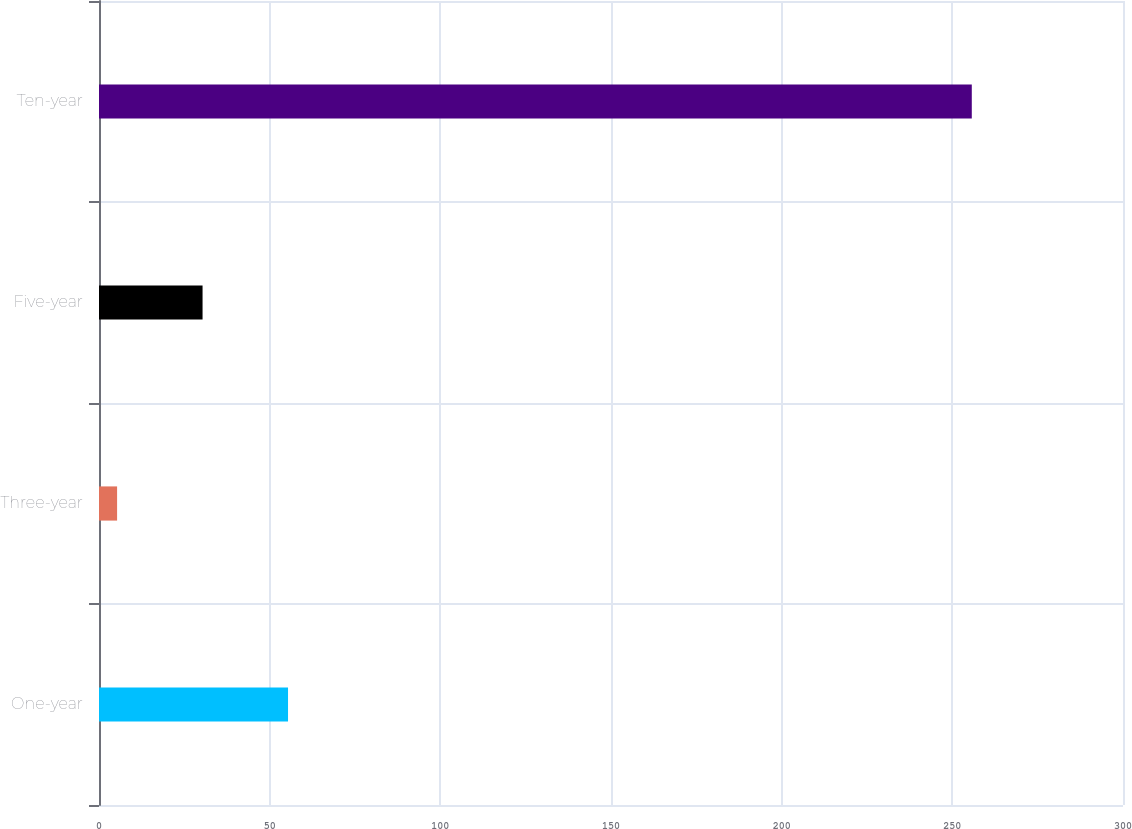Convert chart to OTSL. <chart><loc_0><loc_0><loc_500><loc_500><bar_chart><fcel>One-year<fcel>Three-year<fcel>Five-year<fcel>Ten-year<nl><fcel>55.38<fcel>5.3<fcel>30.34<fcel>255.7<nl></chart> 